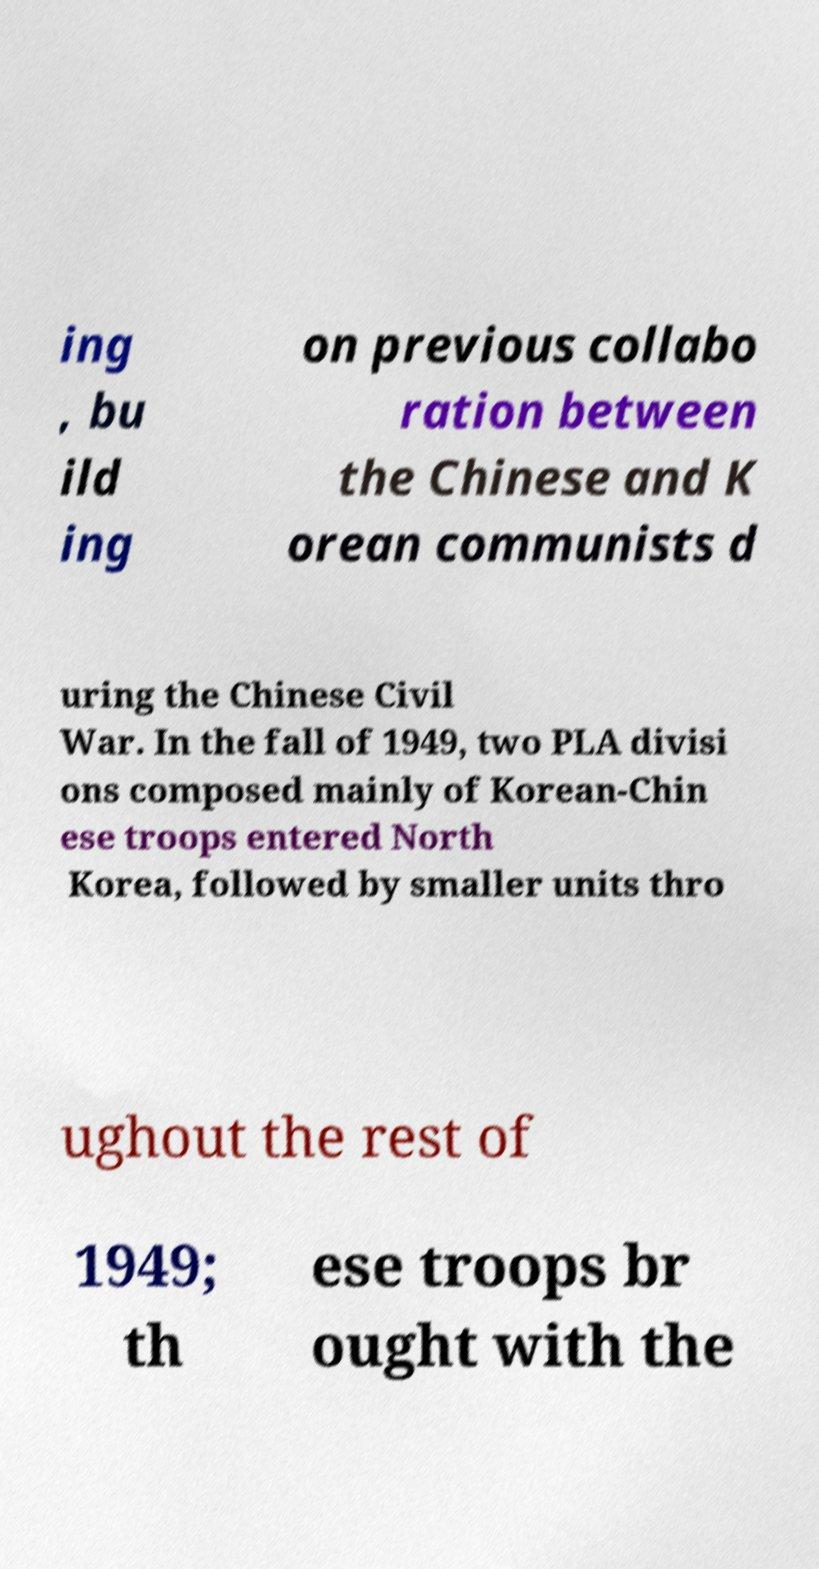Can you accurately transcribe the text from the provided image for me? ing , bu ild ing on previous collabo ration between the Chinese and K orean communists d uring the Chinese Civil War. In the fall of 1949, two PLA divisi ons composed mainly of Korean-Chin ese troops entered North Korea, followed by smaller units thro ughout the rest of 1949; th ese troops br ought with the 